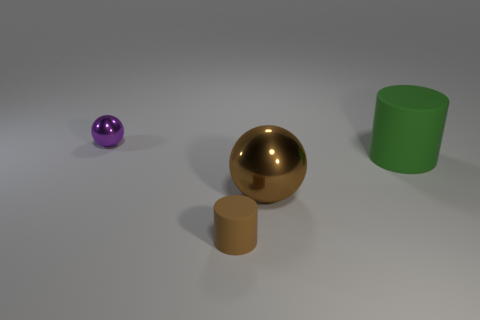There is a small thing behind the big green matte cylinder; what shape is it?
Make the answer very short. Sphere. How many blue objects are metallic things or small shiny cylinders?
Your answer should be very brief. 0. There is another cylinder that is the same material as the large green cylinder; what color is it?
Keep it short and to the point. Brown. Is the color of the large ball the same as the cylinder in front of the green cylinder?
Offer a terse response. Yes. There is a thing that is both behind the small brown rubber cylinder and to the left of the large brown sphere; what color is it?
Your response must be concise. Purple. There is a large green object; how many big balls are behind it?
Offer a very short reply. 0. What number of things are either tiny brown rubber things or objects on the right side of the small matte cylinder?
Offer a very short reply. 3. There is a thing that is behind the large green thing; are there any green matte things to the left of it?
Your answer should be very brief. No. There is a cylinder to the right of the brown matte cylinder; what is its color?
Offer a very short reply. Green. Are there an equal number of small spheres that are in front of the purple object and objects?
Give a very brief answer. No. 